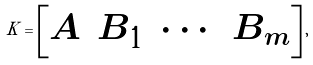Convert formula to latex. <formula><loc_0><loc_0><loc_500><loc_500>K = \begin{bmatrix} A & B _ { 1 } & \cdots & B _ { m } \end{bmatrix} ,</formula> 